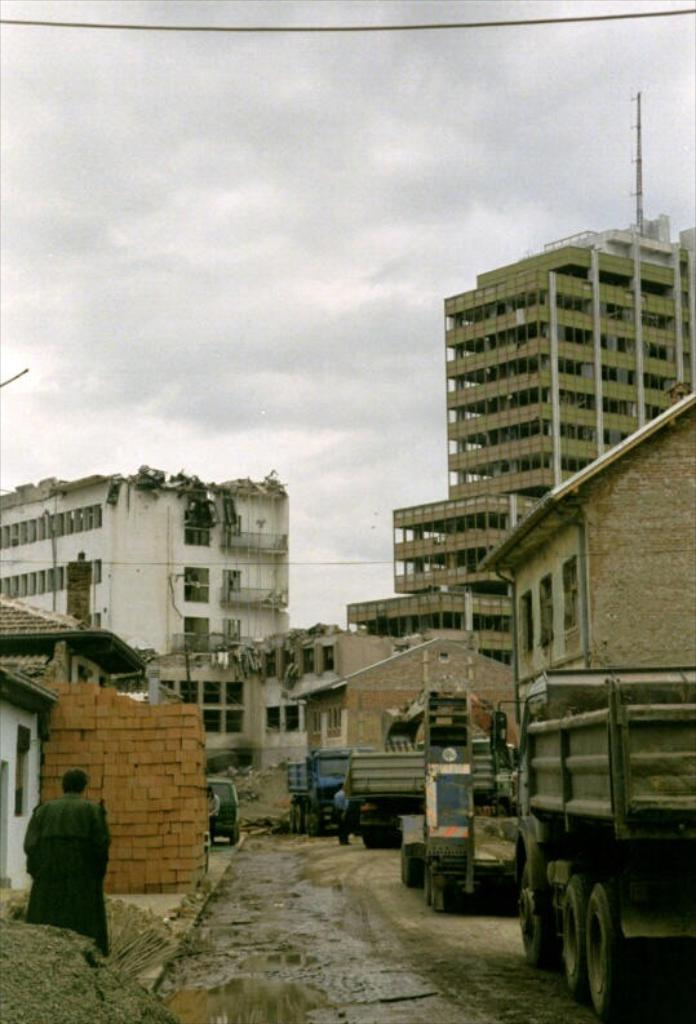What types of objects can be seen in the image? There are vehicles and buildings in the image. What can be observed on the left side of the image? There are cracks on the left side of the image. Are there any living beings present in the image? Yes, there are people in the image. What is visible in the sky in the image? There are clouds in the sky. What type of ice can be seen melting in the image? There is no ice present in the image. What scent is emanating from the lunchroom in the image? There is no lunchroom present in the image. 